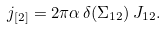<formula> <loc_0><loc_0><loc_500><loc_500>j _ { [ 2 ] } = 2 \pi \alpha \, \delta ( \Sigma _ { 1 2 } ) \, J _ { 1 2 } .</formula> 